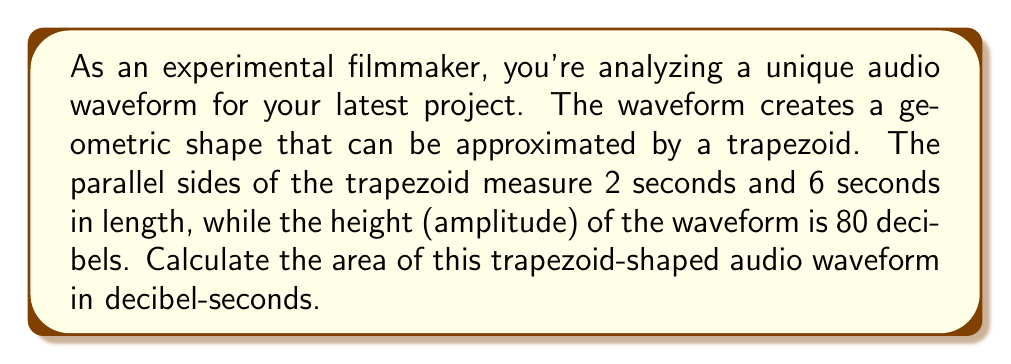Can you answer this question? To solve this problem, we'll use the formula for the area of a trapezoid:

$$A = \frac{1}{2}(b_1 + b_2)h$$

Where:
$A$ = Area of the trapezoid
$b_1$ and $b_2$ = Lengths of the parallel sides
$h$ = Height of the trapezoid

Given:
$b_1 = 2$ seconds
$b_2 = 6$ seconds
$h = 80$ decibels

Let's substitute these values into the formula:

$$A = \frac{1}{2}(2 + 6) \times 80$$
$$A = \frac{1}{2}(8) \times 80$$
$$A = 4 \times 80$$
$$A = 320$$

The units for the area will be decibel-seconds (dB·s), as we're multiplying time (seconds) by amplitude (decibels).

[asy]
unitsize(10mm);
path p = (0,0)--(2,4)--(8,4)--(10,0)--cycle;
draw(p);
label("2s", (1,0), S);
label("6s", (9,0), S);
label("80 dB", (0,2), W);
[/asy]
Answer: 320 dB·s 